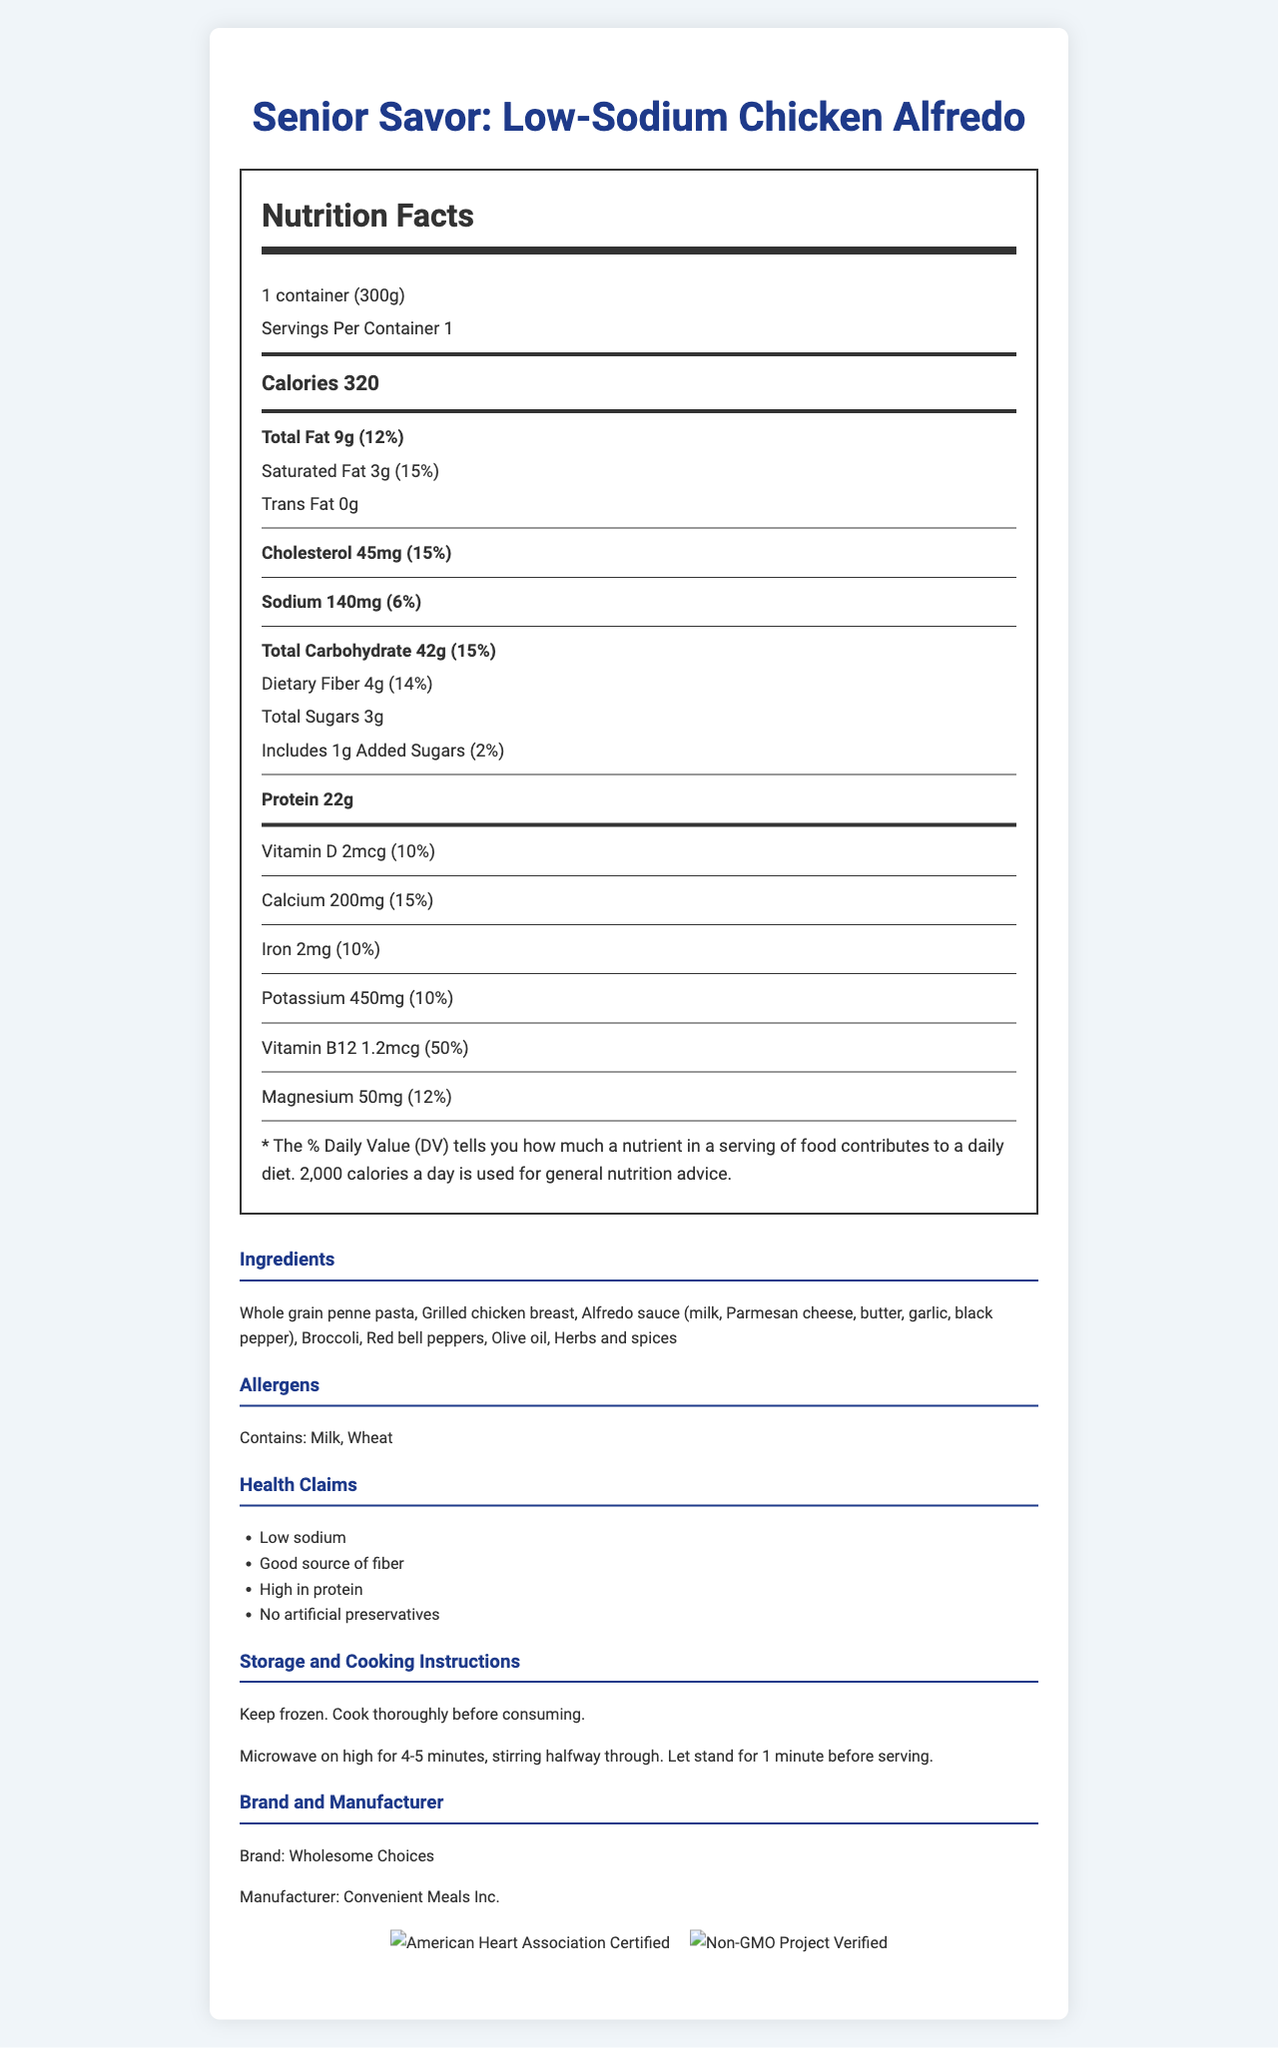what is the serving size? The serving size is explicitly stated at the beginning of the Nutrition Facts section.
Answer: 1 container (300g) how many calories are in one serving? The number of calories per serving is listed in bold within the Nutrition Facts section.
Answer: 320 calories what percentage of the daily value of saturated fat does this meal provide? The daily value percentage for saturated fat is provided right next to the amount of saturated fat in the Nutrition Facts.
Answer: 15% which ingredient is included in the meal? A. Rice B. Whole grain penne pasta C. Potatoes The ingredients list includes "Whole grain penne pasta,” making it the correct answer.
Answer: B is this product considered a low-sodium food? The product is labeled “Low-Sodium” in both the health claims and the sodium content, which is 140mg, considered low.
Answer: Yes how much protein does one serving contain? The protein content is listed in the Nutrition Facts, specifically at the end of the main nutrient list.
Answer: 22g what certifications does this product have? These certifications are displayed at the bottom of the document along with their respective logos.
Answer: American Heart Association Certified, Non-GMO Project Verified which nutrient has the highest daily value percentage? A. Vitamin D B. Calcium C. Vitamin B12 Vitamin B12 has the highest daily value percentage at 50%, compared to 10% for Vitamin D and 15% for Calcium.
Answer: C does this product contain any allergens? The document lists allergens explicitly as “Contains: Milk, Wheat”.
Answer: Yes summarize the main idea of this document. The main body of the document is dedicated to nutrition facts, followed by sections on ingredients, allergens, health claims, storage and cooking instructions, and certifications, summarizing the product's key features.
Answer: The document provides detailed nutritional information for "Senior Savor: Low-Sodium Chicken Alfredo" by Wholesome Choices, emphasizing its low sodium content, high protein, and several certifications. It also includes ingredients, storage and cooking instructions, health claims, and allergens. what is the total amount of potassium in this meal? The amount of potassium is explicitly listed in the Nutrition Facts under the vitamin and mineral section.
Answer: 450mg what is the cooking time for this meal? The cooking instructions specify the exact microwave time required to prepare the meal.
Answer: Microwave on high for 4-5 minutes how should this product be stored? The storage instructions clearly state to keep the product frozen.
Answer: Keep frozen. can you tell if this meal is organic? The document does not provide any information indicating whether the product is organic.
Answer: Not enough information what is the daily value percentage for dietary fiber? The daily value percentage for dietary fiber is listed alongside its amount in the Nutrition Facts.
Answer: 14% 